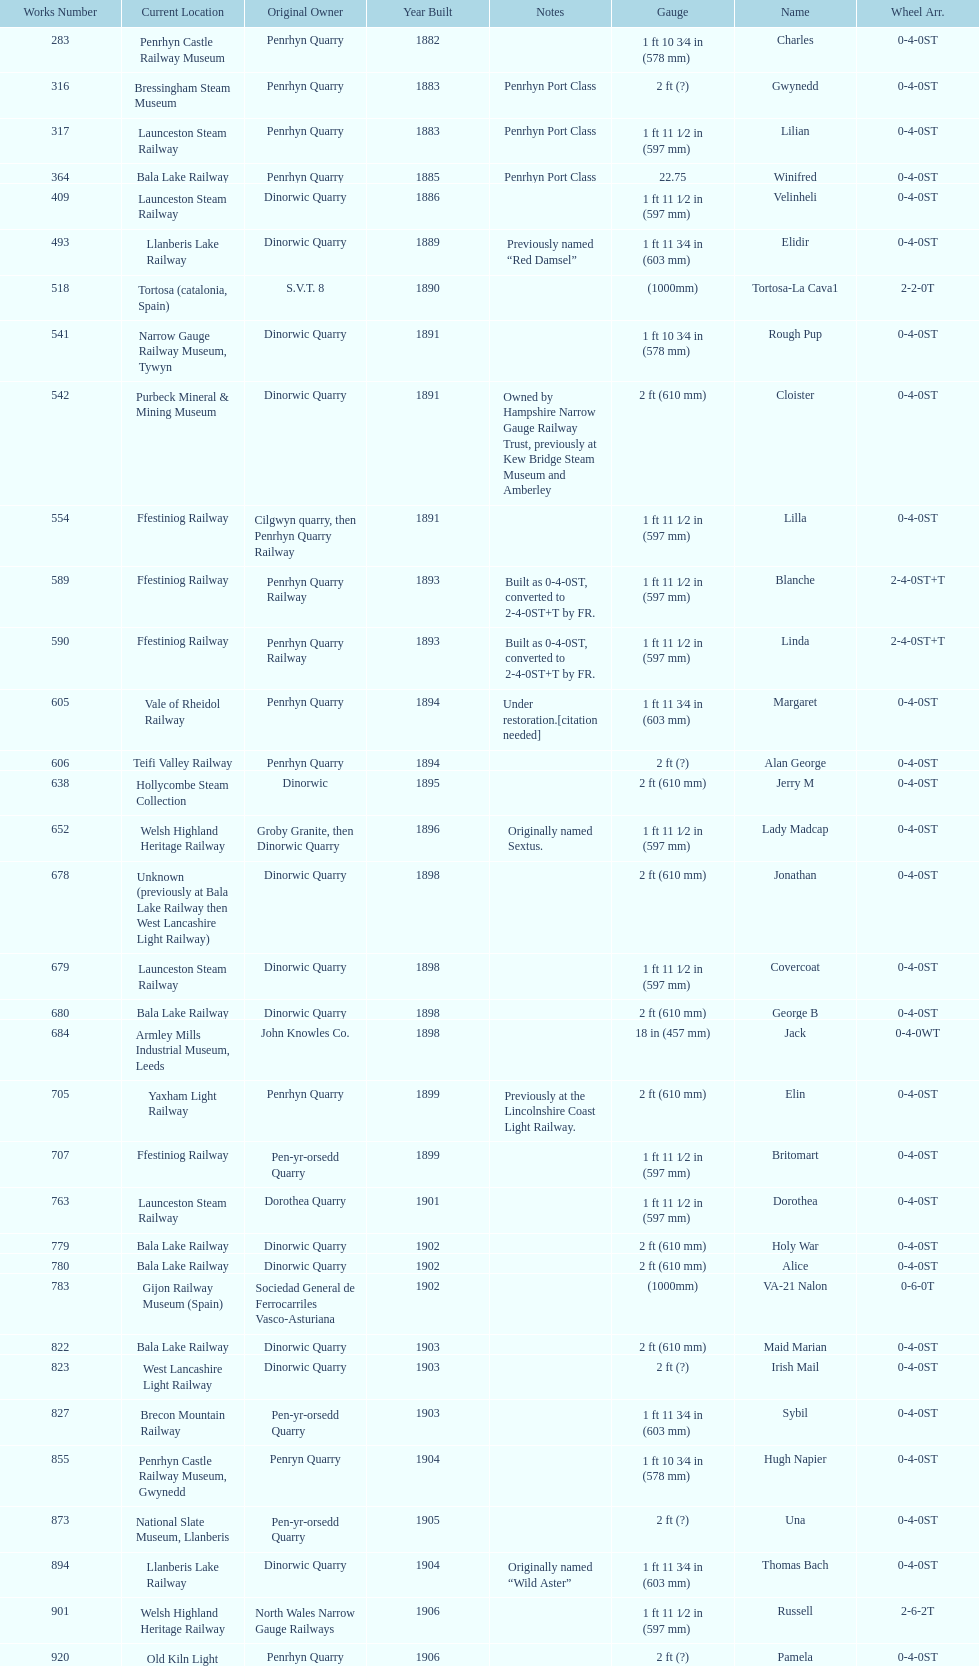Aside from 316, what was the other works number used in 1883? 317. 